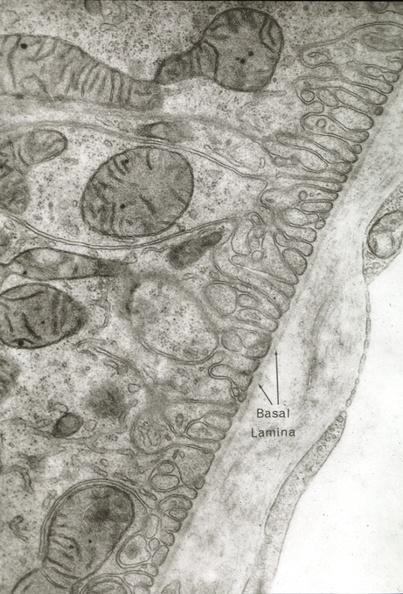s lymphangiomatosis present?
Answer the question using a single word or phrase. No 